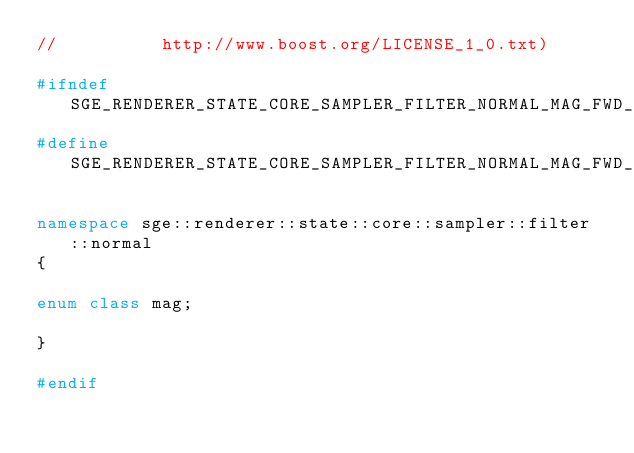<code> <loc_0><loc_0><loc_500><loc_500><_C++_>//          http://www.boost.org/LICENSE_1_0.txt)

#ifndef SGE_RENDERER_STATE_CORE_SAMPLER_FILTER_NORMAL_MAG_FWD_HPP_INCLUDED
#define SGE_RENDERER_STATE_CORE_SAMPLER_FILTER_NORMAL_MAG_FWD_HPP_INCLUDED

namespace sge::renderer::state::core::sampler::filter::normal
{

enum class mag;

}

#endif
</code> 